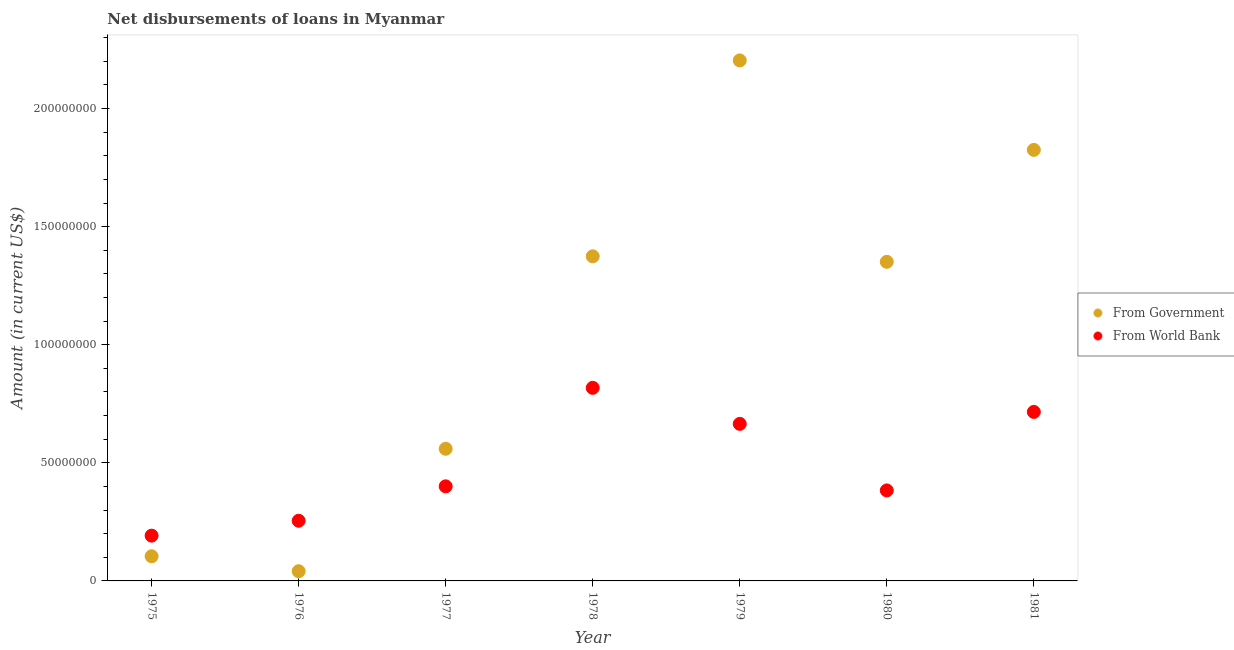Is the number of dotlines equal to the number of legend labels?
Ensure brevity in your answer.  Yes. What is the net disbursements of loan from world bank in 1975?
Provide a succinct answer. 1.92e+07. Across all years, what is the maximum net disbursements of loan from government?
Give a very brief answer. 2.20e+08. Across all years, what is the minimum net disbursements of loan from government?
Your answer should be very brief. 4.12e+06. In which year was the net disbursements of loan from world bank maximum?
Offer a terse response. 1978. In which year was the net disbursements of loan from government minimum?
Provide a succinct answer. 1976. What is the total net disbursements of loan from government in the graph?
Provide a short and direct response. 7.46e+08. What is the difference between the net disbursements of loan from world bank in 1975 and that in 1980?
Your response must be concise. -1.91e+07. What is the difference between the net disbursements of loan from world bank in 1981 and the net disbursements of loan from government in 1980?
Your response must be concise. -6.35e+07. What is the average net disbursements of loan from government per year?
Offer a very short reply. 1.07e+08. In the year 1981, what is the difference between the net disbursements of loan from world bank and net disbursements of loan from government?
Give a very brief answer. -1.11e+08. In how many years, is the net disbursements of loan from world bank greater than 90000000 US$?
Your answer should be very brief. 0. What is the ratio of the net disbursements of loan from government in 1976 to that in 1981?
Give a very brief answer. 0.02. Is the net disbursements of loan from government in 1977 less than that in 1978?
Your answer should be compact. Yes. What is the difference between the highest and the second highest net disbursements of loan from world bank?
Make the answer very short. 1.02e+07. What is the difference between the highest and the lowest net disbursements of loan from government?
Offer a very short reply. 2.16e+08. Is the sum of the net disbursements of loan from world bank in 1976 and 1980 greater than the maximum net disbursements of loan from government across all years?
Give a very brief answer. No. Does the net disbursements of loan from world bank monotonically increase over the years?
Make the answer very short. No. Is the net disbursements of loan from world bank strictly less than the net disbursements of loan from government over the years?
Provide a succinct answer. No. How many dotlines are there?
Your response must be concise. 2. What is the difference between two consecutive major ticks on the Y-axis?
Give a very brief answer. 5.00e+07. Are the values on the major ticks of Y-axis written in scientific E-notation?
Ensure brevity in your answer.  No. Does the graph contain grids?
Your answer should be very brief. No. Where does the legend appear in the graph?
Give a very brief answer. Center right. How many legend labels are there?
Keep it short and to the point. 2. What is the title of the graph?
Make the answer very short. Net disbursements of loans in Myanmar. What is the label or title of the Y-axis?
Keep it short and to the point. Amount (in current US$). What is the Amount (in current US$) in From Government in 1975?
Make the answer very short. 1.04e+07. What is the Amount (in current US$) of From World Bank in 1975?
Your answer should be compact. 1.92e+07. What is the Amount (in current US$) of From Government in 1976?
Give a very brief answer. 4.12e+06. What is the Amount (in current US$) of From World Bank in 1976?
Provide a succinct answer. 2.55e+07. What is the Amount (in current US$) in From Government in 1977?
Your answer should be very brief. 5.59e+07. What is the Amount (in current US$) of From World Bank in 1977?
Your answer should be very brief. 4.00e+07. What is the Amount (in current US$) of From Government in 1978?
Offer a terse response. 1.37e+08. What is the Amount (in current US$) in From World Bank in 1978?
Provide a succinct answer. 8.17e+07. What is the Amount (in current US$) in From Government in 1979?
Give a very brief answer. 2.20e+08. What is the Amount (in current US$) in From World Bank in 1979?
Provide a succinct answer. 6.65e+07. What is the Amount (in current US$) in From Government in 1980?
Ensure brevity in your answer.  1.35e+08. What is the Amount (in current US$) of From World Bank in 1980?
Your answer should be compact. 3.83e+07. What is the Amount (in current US$) in From Government in 1981?
Offer a very short reply. 1.82e+08. What is the Amount (in current US$) in From World Bank in 1981?
Make the answer very short. 7.16e+07. Across all years, what is the maximum Amount (in current US$) in From Government?
Your response must be concise. 2.20e+08. Across all years, what is the maximum Amount (in current US$) in From World Bank?
Make the answer very short. 8.17e+07. Across all years, what is the minimum Amount (in current US$) in From Government?
Ensure brevity in your answer.  4.12e+06. Across all years, what is the minimum Amount (in current US$) of From World Bank?
Your answer should be compact. 1.92e+07. What is the total Amount (in current US$) in From Government in the graph?
Your answer should be very brief. 7.46e+08. What is the total Amount (in current US$) of From World Bank in the graph?
Offer a very short reply. 3.43e+08. What is the difference between the Amount (in current US$) in From Government in 1975 and that in 1976?
Keep it short and to the point. 6.32e+06. What is the difference between the Amount (in current US$) in From World Bank in 1975 and that in 1976?
Provide a short and direct response. -6.30e+06. What is the difference between the Amount (in current US$) in From Government in 1975 and that in 1977?
Your response must be concise. -4.55e+07. What is the difference between the Amount (in current US$) in From World Bank in 1975 and that in 1977?
Give a very brief answer. -2.09e+07. What is the difference between the Amount (in current US$) in From Government in 1975 and that in 1978?
Your answer should be compact. -1.27e+08. What is the difference between the Amount (in current US$) of From World Bank in 1975 and that in 1978?
Make the answer very short. -6.26e+07. What is the difference between the Amount (in current US$) in From Government in 1975 and that in 1979?
Your answer should be compact. -2.10e+08. What is the difference between the Amount (in current US$) of From World Bank in 1975 and that in 1979?
Offer a terse response. -4.73e+07. What is the difference between the Amount (in current US$) in From Government in 1975 and that in 1980?
Offer a terse response. -1.25e+08. What is the difference between the Amount (in current US$) in From World Bank in 1975 and that in 1980?
Your response must be concise. -1.91e+07. What is the difference between the Amount (in current US$) in From Government in 1975 and that in 1981?
Your answer should be very brief. -1.72e+08. What is the difference between the Amount (in current US$) in From World Bank in 1975 and that in 1981?
Your answer should be compact. -5.24e+07. What is the difference between the Amount (in current US$) in From Government in 1976 and that in 1977?
Your answer should be compact. -5.18e+07. What is the difference between the Amount (in current US$) in From World Bank in 1976 and that in 1977?
Ensure brevity in your answer.  -1.46e+07. What is the difference between the Amount (in current US$) of From Government in 1976 and that in 1978?
Offer a terse response. -1.33e+08. What is the difference between the Amount (in current US$) in From World Bank in 1976 and that in 1978?
Provide a succinct answer. -5.63e+07. What is the difference between the Amount (in current US$) in From Government in 1976 and that in 1979?
Your answer should be very brief. -2.16e+08. What is the difference between the Amount (in current US$) of From World Bank in 1976 and that in 1979?
Make the answer very short. -4.10e+07. What is the difference between the Amount (in current US$) of From Government in 1976 and that in 1980?
Your answer should be compact. -1.31e+08. What is the difference between the Amount (in current US$) of From World Bank in 1976 and that in 1980?
Give a very brief answer. -1.28e+07. What is the difference between the Amount (in current US$) in From Government in 1976 and that in 1981?
Your answer should be very brief. -1.78e+08. What is the difference between the Amount (in current US$) of From World Bank in 1976 and that in 1981?
Offer a very short reply. -4.61e+07. What is the difference between the Amount (in current US$) in From Government in 1977 and that in 1978?
Give a very brief answer. -8.15e+07. What is the difference between the Amount (in current US$) of From World Bank in 1977 and that in 1978?
Provide a short and direct response. -4.17e+07. What is the difference between the Amount (in current US$) in From Government in 1977 and that in 1979?
Ensure brevity in your answer.  -1.64e+08. What is the difference between the Amount (in current US$) of From World Bank in 1977 and that in 1979?
Your answer should be compact. -2.64e+07. What is the difference between the Amount (in current US$) in From Government in 1977 and that in 1980?
Offer a very short reply. -7.92e+07. What is the difference between the Amount (in current US$) of From World Bank in 1977 and that in 1980?
Provide a short and direct response. 1.73e+06. What is the difference between the Amount (in current US$) in From Government in 1977 and that in 1981?
Your answer should be very brief. -1.27e+08. What is the difference between the Amount (in current US$) of From World Bank in 1977 and that in 1981?
Offer a very short reply. -3.15e+07. What is the difference between the Amount (in current US$) of From Government in 1978 and that in 1979?
Offer a terse response. -8.29e+07. What is the difference between the Amount (in current US$) of From World Bank in 1978 and that in 1979?
Keep it short and to the point. 1.53e+07. What is the difference between the Amount (in current US$) of From Government in 1978 and that in 1980?
Provide a short and direct response. 2.34e+06. What is the difference between the Amount (in current US$) of From World Bank in 1978 and that in 1980?
Keep it short and to the point. 4.34e+07. What is the difference between the Amount (in current US$) in From Government in 1978 and that in 1981?
Offer a terse response. -4.51e+07. What is the difference between the Amount (in current US$) in From World Bank in 1978 and that in 1981?
Your response must be concise. 1.02e+07. What is the difference between the Amount (in current US$) of From Government in 1979 and that in 1980?
Make the answer very short. 8.53e+07. What is the difference between the Amount (in current US$) in From World Bank in 1979 and that in 1980?
Your answer should be compact. 2.82e+07. What is the difference between the Amount (in current US$) in From Government in 1979 and that in 1981?
Provide a short and direct response. 3.79e+07. What is the difference between the Amount (in current US$) of From World Bank in 1979 and that in 1981?
Your answer should be very brief. -5.07e+06. What is the difference between the Amount (in current US$) of From Government in 1980 and that in 1981?
Your answer should be compact. -4.74e+07. What is the difference between the Amount (in current US$) of From World Bank in 1980 and that in 1981?
Your answer should be very brief. -3.32e+07. What is the difference between the Amount (in current US$) of From Government in 1975 and the Amount (in current US$) of From World Bank in 1976?
Provide a succinct answer. -1.50e+07. What is the difference between the Amount (in current US$) of From Government in 1975 and the Amount (in current US$) of From World Bank in 1977?
Make the answer very short. -2.96e+07. What is the difference between the Amount (in current US$) in From Government in 1975 and the Amount (in current US$) in From World Bank in 1978?
Offer a terse response. -7.13e+07. What is the difference between the Amount (in current US$) in From Government in 1975 and the Amount (in current US$) in From World Bank in 1979?
Your response must be concise. -5.60e+07. What is the difference between the Amount (in current US$) in From Government in 1975 and the Amount (in current US$) in From World Bank in 1980?
Make the answer very short. -2.79e+07. What is the difference between the Amount (in current US$) in From Government in 1975 and the Amount (in current US$) in From World Bank in 1981?
Your response must be concise. -6.11e+07. What is the difference between the Amount (in current US$) in From Government in 1976 and the Amount (in current US$) in From World Bank in 1977?
Your answer should be very brief. -3.59e+07. What is the difference between the Amount (in current US$) in From Government in 1976 and the Amount (in current US$) in From World Bank in 1978?
Your answer should be very brief. -7.76e+07. What is the difference between the Amount (in current US$) in From Government in 1976 and the Amount (in current US$) in From World Bank in 1979?
Provide a succinct answer. -6.24e+07. What is the difference between the Amount (in current US$) of From Government in 1976 and the Amount (in current US$) of From World Bank in 1980?
Make the answer very short. -3.42e+07. What is the difference between the Amount (in current US$) of From Government in 1976 and the Amount (in current US$) of From World Bank in 1981?
Make the answer very short. -6.74e+07. What is the difference between the Amount (in current US$) of From Government in 1977 and the Amount (in current US$) of From World Bank in 1978?
Make the answer very short. -2.58e+07. What is the difference between the Amount (in current US$) of From Government in 1977 and the Amount (in current US$) of From World Bank in 1979?
Offer a terse response. -1.05e+07. What is the difference between the Amount (in current US$) of From Government in 1977 and the Amount (in current US$) of From World Bank in 1980?
Ensure brevity in your answer.  1.76e+07. What is the difference between the Amount (in current US$) of From Government in 1977 and the Amount (in current US$) of From World Bank in 1981?
Your response must be concise. -1.56e+07. What is the difference between the Amount (in current US$) of From Government in 1978 and the Amount (in current US$) of From World Bank in 1979?
Your answer should be compact. 7.09e+07. What is the difference between the Amount (in current US$) of From Government in 1978 and the Amount (in current US$) of From World Bank in 1980?
Provide a succinct answer. 9.91e+07. What is the difference between the Amount (in current US$) in From Government in 1978 and the Amount (in current US$) in From World Bank in 1981?
Keep it short and to the point. 6.59e+07. What is the difference between the Amount (in current US$) in From Government in 1979 and the Amount (in current US$) in From World Bank in 1980?
Provide a short and direct response. 1.82e+08. What is the difference between the Amount (in current US$) in From Government in 1979 and the Amount (in current US$) in From World Bank in 1981?
Provide a short and direct response. 1.49e+08. What is the difference between the Amount (in current US$) of From Government in 1980 and the Amount (in current US$) of From World Bank in 1981?
Make the answer very short. 6.35e+07. What is the average Amount (in current US$) in From Government per year?
Make the answer very short. 1.07e+08. What is the average Amount (in current US$) in From World Bank per year?
Provide a short and direct response. 4.90e+07. In the year 1975, what is the difference between the Amount (in current US$) of From Government and Amount (in current US$) of From World Bank?
Offer a terse response. -8.73e+06. In the year 1976, what is the difference between the Amount (in current US$) in From Government and Amount (in current US$) in From World Bank?
Make the answer very short. -2.14e+07. In the year 1977, what is the difference between the Amount (in current US$) of From Government and Amount (in current US$) of From World Bank?
Provide a short and direct response. 1.59e+07. In the year 1978, what is the difference between the Amount (in current US$) of From Government and Amount (in current US$) of From World Bank?
Give a very brief answer. 5.57e+07. In the year 1979, what is the difference between the Amount (in current US$) of From Government and Amount (in current US$) of From World Bank?
Make the answer very short. 1.54e+08. In the year 1980, what is the difference between the Amount (in current US$) in From Government and Amount (in current US$) in From World Bank?
Ensure brevity in your answer.  9.68e+07. In the year 1981, what is the difference between the Amount (in current US$) of From Government and Amount (in current US$) of From World Bank?
Keep it short and to the point. 1.11e+08. What is the ratio of the Amount (in current US$) in From Government in 1975 to that in 1976?
Make the answer very short. 2.54. What is the ratio of the Amount (in current US$) in From World Bank in 1975 to that in 1976?
Your answer should be compact. 0.75. What is the ratio of the Amount (in current US$) of From Government in 1975 to that in 1977?
Provide a succinct answer. 0.19. What is the ratio of the Amount (in current US$) in From World Bank in 1975 to that in 1977?
Offer a very short reply. 0.48. What is the ratio of the Amount (in current US$) in From Government in 1975 to that in 1978?
Provide a short and direct response. 0.08. What is the ratio of the Amount (in current US$) of From World Bank in 1975 to that in 1978?
Give a very brief answer. 0.23. What is the ratio of the Amount (in current US$) of From Government in 1975 to that in 1979?
Provide a succinct answer. 0.05. What is the ratio of the Amount (in current US$) in From World Bank in 1975 to that in 1979?
Give a very brief answer. 0.29. What is the ratio of the Amount (in current US$) in From Government in 1975 to that in 1980?
Ensure brevity in your answer.  0.08. What is the ratio of the Amount (in current US$) of From World Bank in 1975 to that in 1980?
Your response must be concise. 0.5. What is the ratio of the Amount (in current US$) of From Government in 1975 to that in 1981?
Ensure brevity in your answer.  0.06. What is the ratio of the Amount (in current US$) of From World Bank in 1975 to that in 1981?
Offer a very short reply. 0.27. What is the ratio of the Amount (in current US$) in From Government in 1976 to that in 1977?
Provide a succinct answer. 0.07. What is the ratio of the Amount (in current US$) in From World Bank in 1976 to that in 1977?
Your answer should be very brief. 0.64. What is the ratio of the Amount (in current US$) of From Government in 1976 to that in 1978?
Your response must be concise. 0.03. What is the ratio of the Amount (in current US$) in From World Bank in 1976 to that in 1978?
Ensure brevity in your answer.  0.31. What is the ratio of the Amount (in current US$) of From Government in 1976 to that in 1979?
Offer a very short reply. 0.02. What is the ratio of the Amount (in current US$) of From World Bank in 1976 to that in 1979?
Give a very brief answer. 0.38. What is the ratio of the Amount (in current US$) in From Government in 1976 to that in 1980?
Give a very brief answer. 0.03. What is the ratio of the Amount (in current US$) in From World Bank in 1976 to that in 1980?
Offer a terse response. 0.66. What is the ratio of the Amount (in current US$) of From Government in 1976 to that in 1981?
Provide a succinct answer. 0.02. What is the ratio of the Amount (in current US$) of From World Bank in 1976 to that in 1981?
Your answer should be very brief. 0.36. What is the ratio of the Amount (in current US$) in From Government in 1977 to that in 1978?
Offer a terse response. 0.41. What is the ratio of the Amount (in current US$) of From World Bank in 1977 to that in 1978?
Your response must be concise. 0.49. What is the ratio of the Amount (in current US$) in From Government in 1977 to that in 1979?
Offer a terse response. 0.25. What is the ratio of the Amount (in current US$) in From World Bank in 1977 to that in 1979?
Make the answer very short. 0.6. What is the ratio of the Amount (in current US$) in From Government in 1977 to that in 1980?
Your response must be concise. 0.41. What is the ratio of the Amount (in current US$) in From World Bank in 1977 to that in 1980?
Your response must be concise. 1.05. What is the ratio of the Amount (in current US$) in From Government in 1977 to that in 1981?
Provide a short and direct response. 0.31. What is the ratio of the Amount (in current US$) of From World Bank in 1977 to that in 1981?
Offer a very short reply. 0.56. What is the ratio of the Amount (in current US$) of From Government in 1978 to that in 1979?
Keep it short and to the point. 0.62. What is the ratio of the Amount (in current US$) in From World Bank in 1978 to that in 1979?
Offer a very short reply. 1.23. What is the ratio of the Amount (in current US$) of From Government in 1978 to that in 1980?
Make the answer very short. 1.02. What is the ratio of the Amount (in current US$) in From World Bank in 1978 to that in 1980?
Provide a short and direct response. 2.13. What is the ratio of the Amount (in current US$) of From Government in 1978 to that in 1981?
Provide a short and direct response. 0.75. What is the ratio of the Amount (in current US$) in From World Bank in 1978 to that in 1981?
Provide a succinct answer. 1.14. What is the ratio of the Amount (in current US$) in From Government in 1979 to that in 1980?
Your answer should be compact. 1.63. What is the ratio of the Amount (in current US$) of From World Bank in 1979 to that in 1980?
Keep it short and to the point. 1.74. What is the ratio of the Amount (in current US$) in From Government in 1979 to that in 1981?
Your answer should be compact. 1.21. What is the ratio of the Amount (in current US$) in From World Bank in 1979 to that in 1981?
Offer a terse response. 0.93. What is the ratio of the Amount (in current US$) in From Government in 1980 to that in 1981?
Keep it short and to the point. 0.74. What is the ratio of the Amount (in current US$) in From World Bank in 1980 to that in 1981?
Your answer should be very brief. 0.54. What is the difference between the highest and the second highest Amount (in current US$) of From Government?
Provide a short and direct response. 3.79e+07. What is the difference between the highest and the second highest Amount (in current US$) in From World Bank?
Make the answer very short. 1.02e+07. What is the difference between the highest and the lowest Amount (in current US$) of From Government?
Offer a very short reply. 2.16e+08. What is the difference between the highest and the lowest Amount (in current US$) of From World Bank?
Your response must be concise. 6.26e+07. 